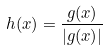<formula> <loc_0><loc_0><loc_500><loc_500>h ( x ) = { \frac { g ( x ) } { | g ( x ) | } }</formula> 